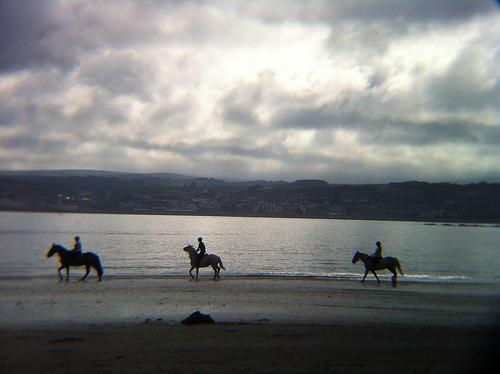Question: where is this shot?
Choices:
A. Cliffside.
B. Ocean.
C. Lake.
D. Beach.
Answer with the letter. Answer: D Question: what animal is shown?
Choices:
A. Donkeys.
B. Dogs.
C. Cats.
D. Horses.
Answer with the letter. Answer: D Question: what is the focus?
Choices:
A. People walking on a beach.
B. Donkeys walking.
C. Silhouette horses riding on beach.
D. Dogs running on a beach.
Answer with the letter. Answer: C Question: how many cars are shown?
Choices:
A. 0.
B. 1.
C. 2.
D. 3.
Answer with the letter. Answer: A 